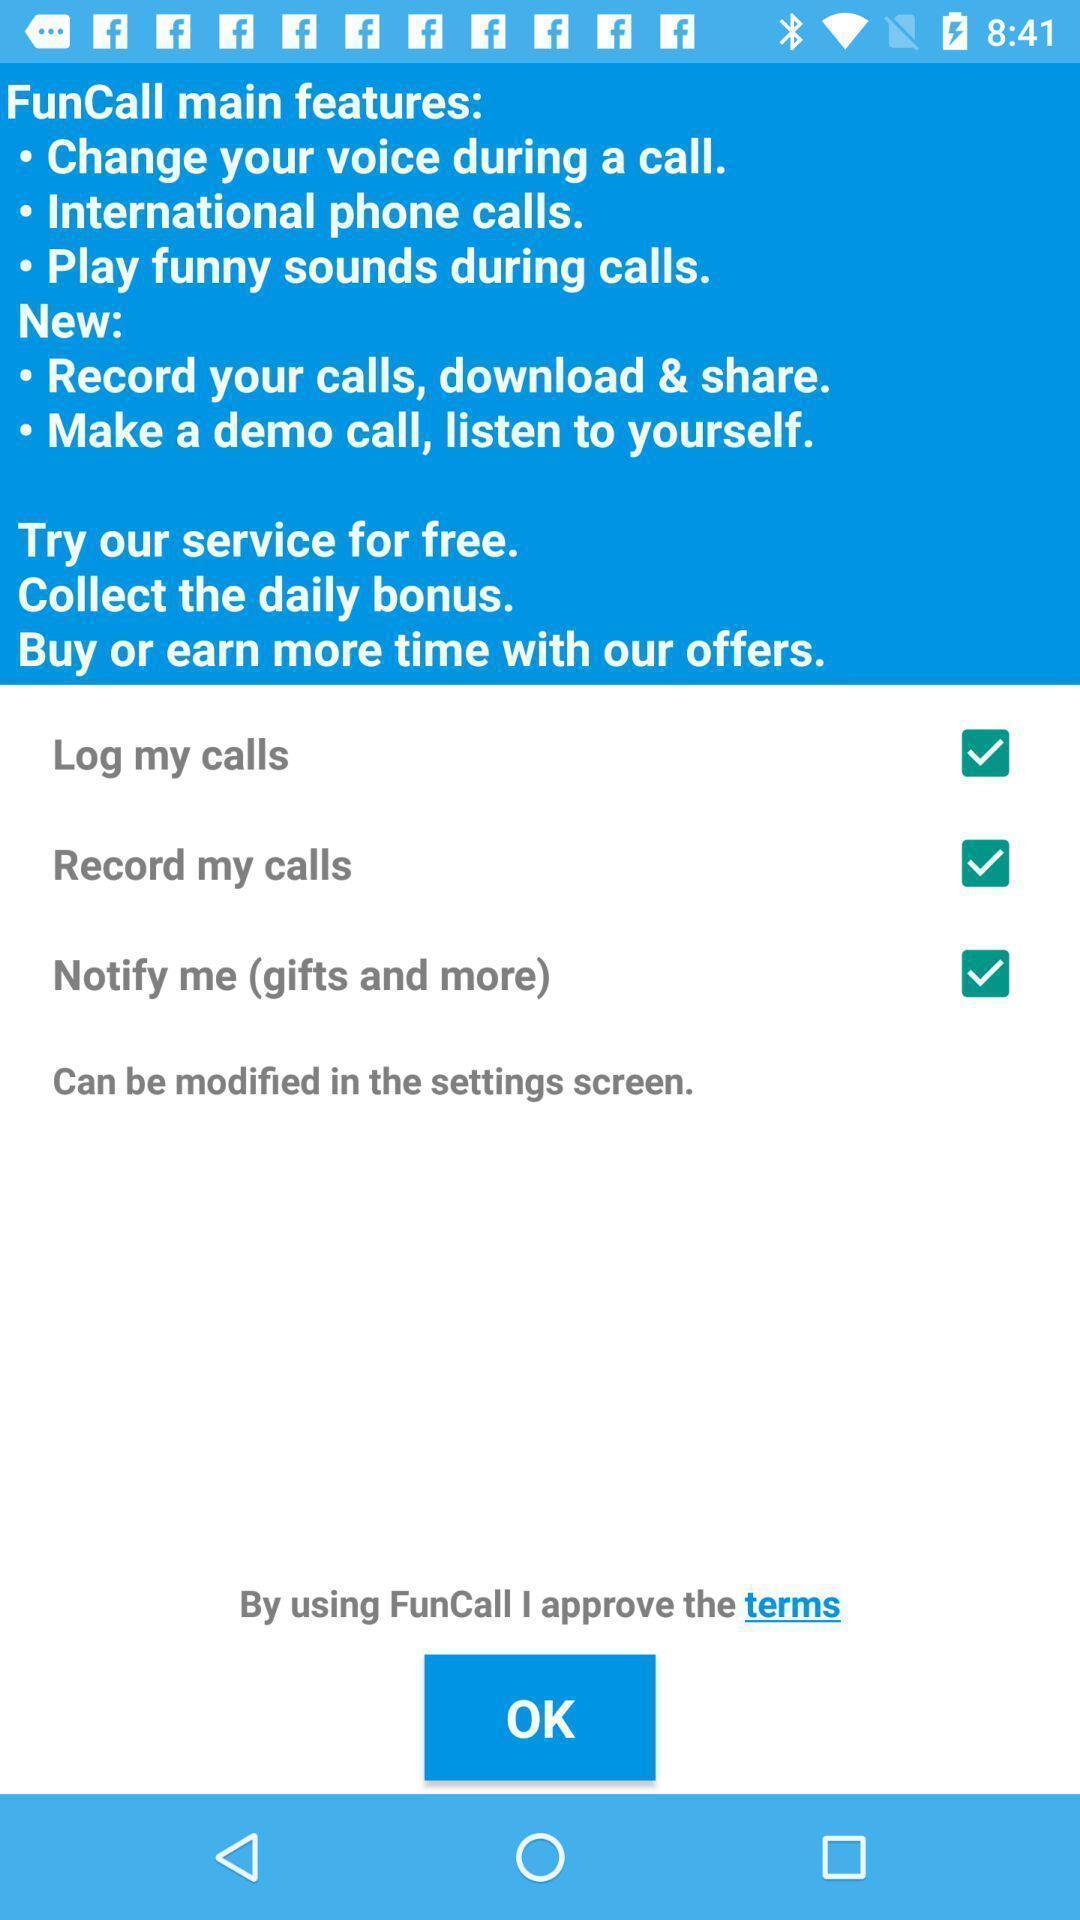Describe the content in this image. Settings menu for a prank calling app. 